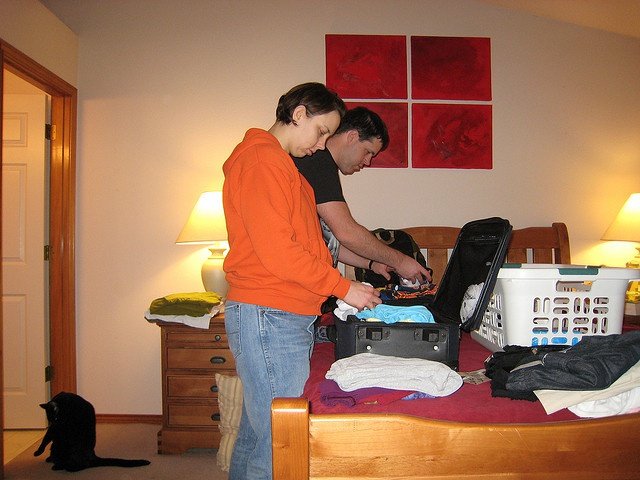Describe the objects in this image and their specific colors. I can see people in brown, red, gray, and darkgray tones, bed in brown, lightgray, and black tones, suitcase in brown, black, gray, and lightblue tones, people in brown, black, and maroon tones, and cat in brown, black, and maroon tones in this image. 